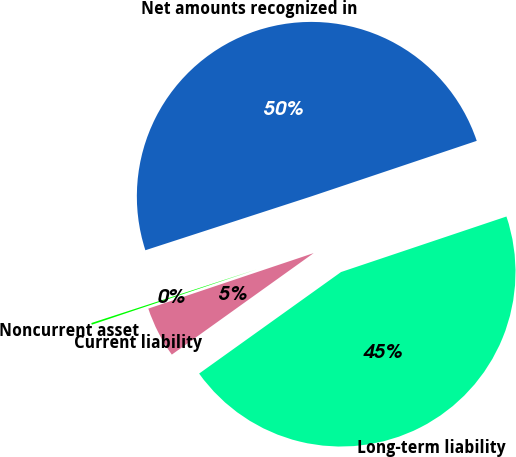Convert chart. <chart><loc_0><loc_0><loc_500><loc_500><pie_chart><fcel>Noncurrent asset<fcel>Current liability<fcel>Long-term liability<fcel>Net amounts recognized in<nl><fcel>0.16%<fcel>4.73%<fcel>45.27%<fcel>49.84%<nl></chart> 